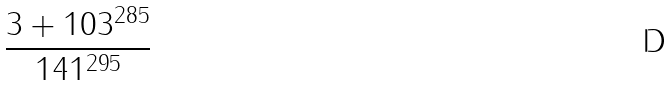<formula> <loc_0><loc_0><loc_500><loc_500>\frac { 3 + 1 0 3 ^ { 2 8 5 } } { 1 4 1 ^ { 2 9 5 } }</formula> 